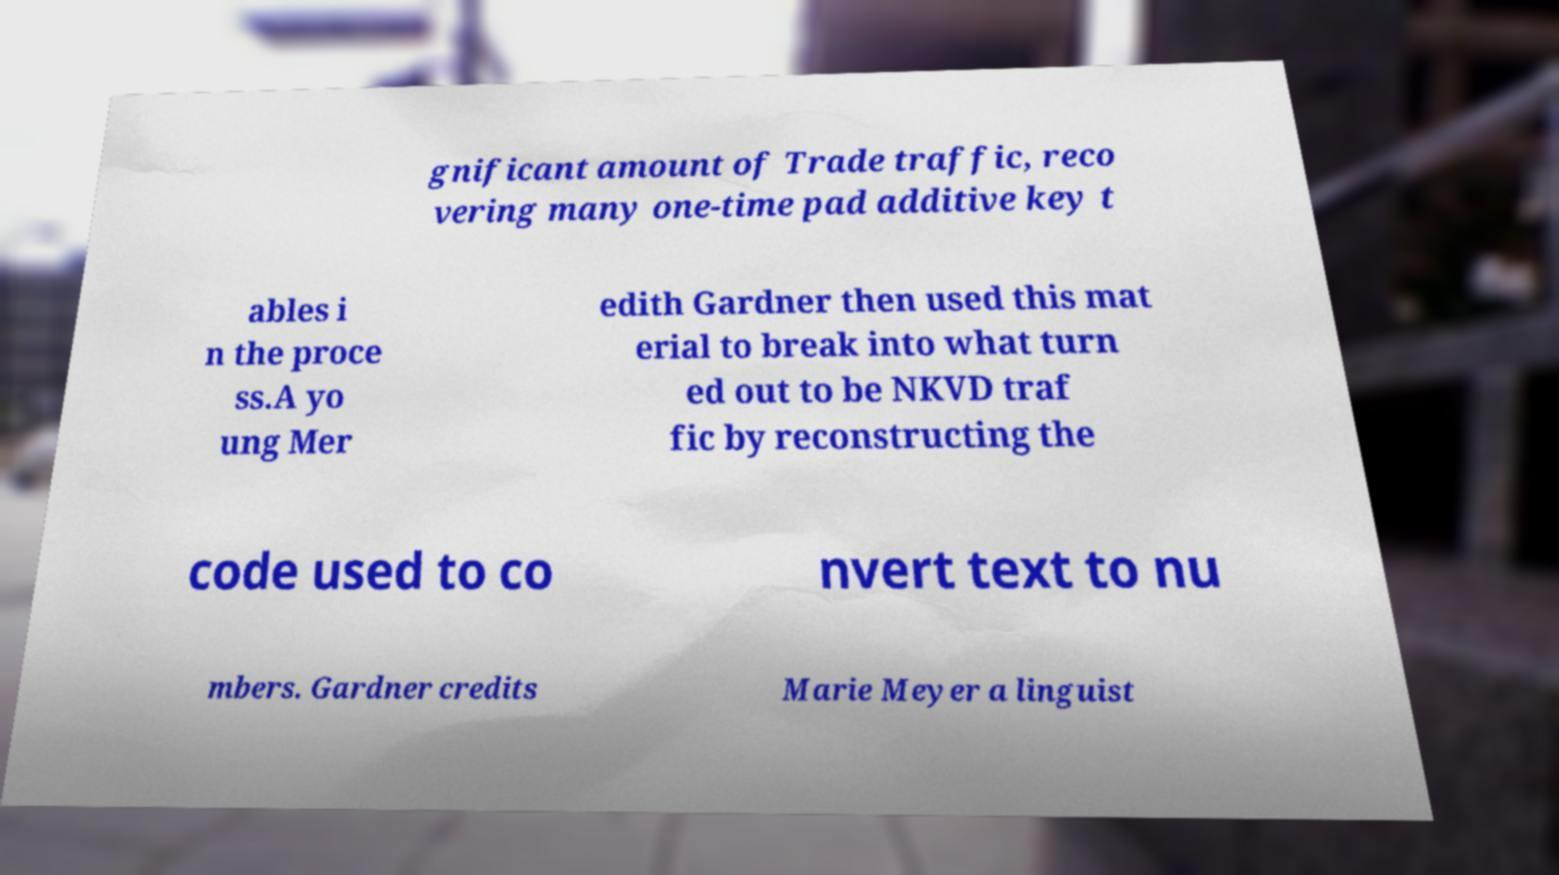Please read and relay the text visible in this image. What does it say? gnificant amount of Trade traffic, reco vering many one-time pad additive key t ables i n the proce ss.A yo ung Mer edith Gardner then used this mat erial to break into what turn ed out to be NKVD traf fic by reconstructing the code used to co nvert text to nu mbers. Gardner credits Marie Meyer a linguist 